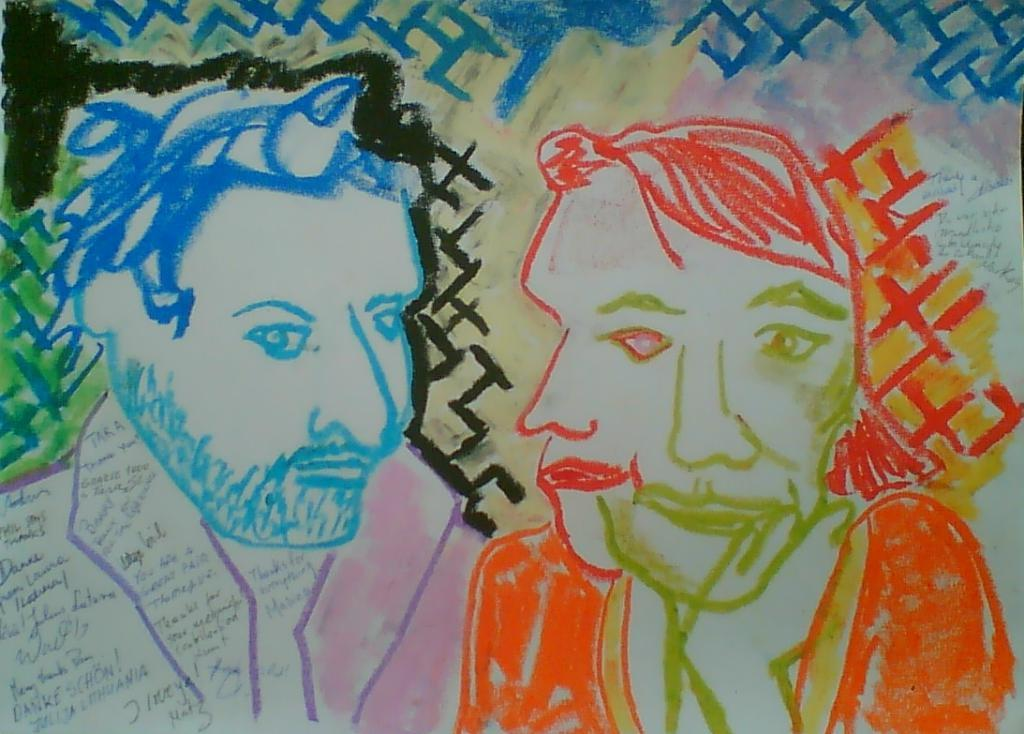What is on the paper in the image? There are drawings on the paper. What do the drawings depict? The drawings depict people. What medium was used to create the drawings? The drawings were made using crayons. Is there a volcano erupting in the background of the drawings? There is no volcano present in the image; the drawings depict people. What type of poison is being used in the drawings? There is no poison present in the image; the drawings were made using crayons. 